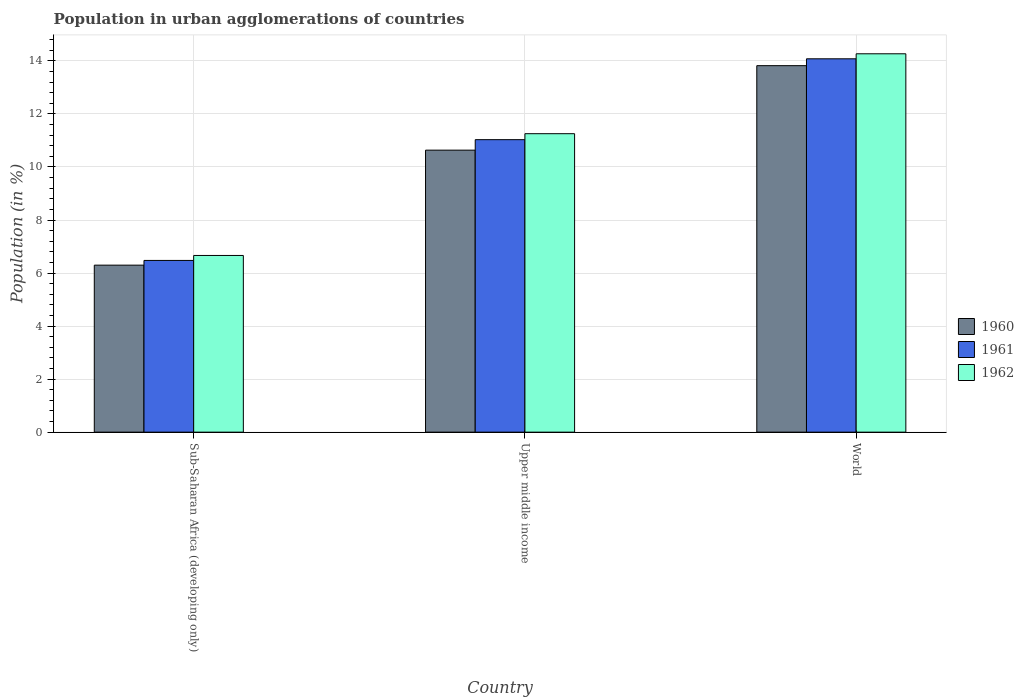How many groups of bars are there?
Your answer should be compact. 3. Are the number of bars per tick equal to the number of legend labels?
Your response must be concise. Yes. How many bars are there on the 2nd tick from the right?
Your response must be concise. 3. What is the label of the 2nd group of bars from the left?
Offer a very short reply. Upper middle income. What is the percentage of population in urban agglomerations in 1962 in World?
Offer a very short reply. 14.27. Across all countries, what is the maximum percentage of population in urban agglomerations in 1961?
Make the answer very short. 14.08. Across all countries, what is the minimum percentage of population in urban agglomerations in 1962?
Keep it short and to the point. 6.66. In which country was the percentage of population in urban agglomerations in 1960 maximum?
Provide a succinct answer. World. In which country was the percentage of population in urban agglomerations in 1960 minimum?
Provide a short and direct response. Sub-Saharan Africa (developing only). What is the total percentage of population in urban agglomerations in 1962 in the graph?
Provide a succinct answer. 32.19. What is the difference between the percentage of population in urban agglomerations in 1962 in Sub-Saharan Africa (developing only) and that in World?
Your answer should be compact. -7.61. What is the difference between the percentage of population in urban agglomerations in 1960 in Upper middle income and the percentage of population in urban agglomerations in 1961 in World?
Provide a succinct answer. -3.45. What is the average percentage of population in urban agglomerations in 1961 per country?
Your answer should be very brief. 10.53. What is the difference between the percentage of population in urban agglomerations of/in 1960 and percentage of population in urban agglomerations of/in 1962 in Sub-Saharan Africa (developing only)?
Provide a short and direct response. -0.37. What is the ratio of the percentage of population in urban agglomerations in 1960 in Sub-Saharan Africa (developing only) to that in World?
Provide a short and direct response. 0.46. Is the percentage of population in urban agglomerations in 1960 in Sub-Saharan Africa (developing only) less than that in World?
Offer a very short reply. Yes. What is the difference between the highest and the second highest percentage of population in urban agglomerations in 1961?
Make the answer very short. -3.05. What is the difference between the highest and the lowest percentage of population in urban agglomerations in 1960?
Your response must be concise. 7.52. In how many countries, is the percentage of population in urban agglomerations in 1962 greater than the average percentage of population in urban agglomerations in 1962 taken over all countries?
Give a very brief answer. 2. What does the 1st bar from the left in Upper middle income represents?
Your answer should be compact. 1960. What does the 3rd bar from the right in World represents?
Give a very brief answer. 1960. Is it the case that in every country, the sum of the percentage of population in urban agglomerations in 1961 and percentage of population in urban agglomerations in 1962 is greater than the percentage of population in urban agglomerations in 1960?
Give a very brief answer. Yes. How many bars are there?
Provide a succinct answer. 9. Are all the bars in the graph horizontal?
Offer a very short reply. No. What is the difference between two consecutive major ticks on the Y-axis?
Provide a short and direct response. 2. Are the values on the major ticks of Y-axis written in scientific E-notation?
Make the answer very short. No. What is the title of the graph?
Offer a terse response. Population in urban agglomerations of countries. What is the label or title of the Y-axis?
Provide a succinct answer. Population (in %). What is the Population (in %) of 1960 in Sub-Saharan Africa (developing only)?
Make the answer very short. 6.3. What is the Population (in %) in 1961 in Sub-Saharan Africa (developing only)?
Make the answer very short. 6.48. What is the Population (in %) of 1962 in Sub-Saharan Africa (developing only)?
Your response must be concise. 6.66. What is the Population (in %) of 1960 in Upper middle income?
Provide a short and direct response. 10.63. What is the Population (in %) in 1961 in Upper middle income?
Provide a succinct answer. 11.03. What is the Population (in %) in 1962 in Upper middle income?
Offer a very short reply. 11.26. What is the Population (in %) in 1960 in World?
Give a very brief answer. 13.82. What is the Population (in %) of 1961 in World?
Provide a succinct answer. 14.08. What is the Population (in %) of 1962 in World?
Offer a very short reply. 14.27. Across all countries, what is the maximum Population (in %) in 1960?
Your response must be concise. 13.82. Across all countries, what is the maximum Population (in %) of 1961?
Give a very brief answer. 14.08. Across all countries, what is the maximum Population (in %) in 1962?
Offer a terse response. 14.27. Across all countries, what is the minimum Population (in %) in 1960?
Ensure brevity in your answer.  6.3. Across all countries, what is the minimum Population (in %) in 1961?
Give a very brief answer. 6.48. Across all countries, what is the minimum Population (in %) of 1962?
Make the answer very short. 6.66. What is the total Population (in %) of 1960 in the graph?
Ensure brevity in your answer.  30.75. What is the total Population (in %) in 1961 in the graph?
Offer a very short reply. 31.59. What is the total Population (in %) in 1962 in the graph?
Make the answer very short. 32.19. What is the difference between the Population (in %) of 1960 in Sub-Saharan Africa (developing only) and that in Upper middle income?
Give a very brief answer. -4.34. What is the difference between the Population (in %) of 1961 in Sub-Saharan Africa (developing only) and that in Upper middle income?
Your response must be concise. -4.55. What is the difference between the Population (in %) of 1962 in Sub-Saharan Africa (developing only) and that in Upper middle income?
Keep it short and to the point. -4.59. What is the difference between the Population (in %) of 1960 in Sub-Saharan Africa (developing only) and that in World?
Provide a succinct answer. -7.52. What is the difference between the Population (in %) in 1961 in Sub-Saharan Africa (developing only) and that in World?
Your response must be concise. -7.6. What is the difference between the Population (in %) of 1962 in Sub-Saharan Africa (developing only) and that in World?
Offer a terse response. -7.61. What is the difference between the Population (in %) in 1960 in Upper middle income and that in World?
Ensure brevity in your answer.  -3.19. What is the difference between the Population (in %) of 1961 in Upper middle income and that in World?
Make the answer very short. -3.05. What is the difference between the Population (in %) in 1962 in Upper middle income and that in World?
Provide a short and direct response. -3.01. What is the difference between the Population (in %) in 1960 in Sub-Saharan Africa (developing only) and the Population (in %) in 1961 in Upper middle income?
Make the answer very short. -4.73. What is the difference between the Population (in %) of 1960 in Sub-Saharan Africa (developing only) and the Population (in %) of 1962 in Upper middle income?
Your answer should be compact. -4.96. What is the difference between the Population (in %) of 1961 in Sub-Saharan Africa (developing only) and the Population (in %) of 1962 in Upper middle income?
Make the answer very short. -4.78. What is the difference between the Population (in %) in 1960 in Sub-Saharan Africa (developing only) and the Population (in %) in 1961 in World?
Offer a very short reply. -7.78. What is the difference between the Population (in %) in 1960 in Sub-Saharan Africa (developing only) and the Population (in %) in 1962 in World?
Keep it short and to the point. -7.97. What is the difference between the Population (in %) of 1961 in Sub-Saharan Africa (developing only) and the Population (in %) of 1962 in World?
Your answer should be compact. -7.79. What is the difference between the Population (in %) in 1960 in Upper middle income and the Population (in %) in 1961 in World?
Offer a terse response. -3.45. What is the difference between the Population (in %) of 1960 in Upper middle income and the Population (in %) of 1962 in World?
Give a very brief answer. -3.63. What is the difference between the Population (in %) in 1961 in Upper middle income and the Population (in %) in 1962 in World?
Ensure brevity in your answer.  -3.24. What is the average Population (in %) in 1960 per country?
Your answer should be very brief. 10.25. What is the average Population (in %) of 1961 per country?
Offer a terse response. 10.53. What is the average Population (in %) of 1962 per country?
Your answer should be compact. 10.73. What is the difference between the Population (in %) of 1960 and Population (in %) of 1961 in Sub-Saharan Africa (developing only)?
Provide a short and direct response. -0.18. What is the difference between the Population (in %) of 1960 and Population (in %) of 1962 in Sub-Saharan Africa (developing only)?
Offer a very short reply. -0.36. What is the difference between the Population (in %) in 1961 and Population (in %) in 1962 in Sub-Saharan Africa (developing only)?
Keep it short and to the point. -0.19. What is the difference between the Population (in %) in 1960 and Population (in %) in 1961 in Upper middle income?
Offer a terse response. -0.4. What is the difference between the Population (in %) of 1960 and Population (in %) of 1962 in Upper middle income?
Your answer should be very brief. -0.62. What is the difference between the Population (in %) of 1961 and Population (in %) of 1962 in Upper middle income?
Your answer should be compact. -0.23. What is the difference between the Population (in %) in 1960 and Population (in %) in 1961 in World?
Your answer should be compact. -0.26. What is the difference between the Population (in %) of 1960 and Population (in %) of 1962 in World?
Make the answer very short. -0.45. What is the difference between the Population (in %) of 1961 and Population (in %) of 1962 in World?
Your response must be concise. -0.19. What is the ratio of the Population (in %) in 1960 in Sub-Saharan Africa (developing only) to that in Upper middle income?
Make the answer very short. 0.59. What is the ratio of the Population (in %) in 1961 in Sub-Saharan Africa (developing only) to that in Upper middle income?
Make the answer very short. 0.59. What is the ratio of the Population (in %) of 1962 in Sub-Saharan Africa (developing only) to that in Upper middle income?
Provide a succinct answer. 0.59. What is the ratio of the Population (in %) of 1960 in Sub-Saharan Africa (developing only) to that in World?
Offer a terse response. 0.46. What is the ratio of the Population (in %) in 1961 in Sub-Saharan Africa (developing only) to that in World?
Give a very brief answer. 0.46. What is the ratio of the Population (in %) of 1962 in Sub-Saharan Africa (developing only) to that in World?
Offer a very short reply. 0.47. What is the ratio of the Population (in %) of 1960 in Upper middle income to that in World?
Your answer should be very brief. 0.77. What is the ratio of the Population (in %) of 1961 in Upper middle income to that in World?
Keep it short and to the point. 0.78. What is the ratio of the Population (in %) of 1962 in Upper middle income to that in World?
Give a very brief answer. 0.79. What is the difference between the highest and the second highest Population (in %) in 1960?
Your response must be concise. 3.19. What is the difference between the highest and the second highest Population (in %) of 1961?
Your answer should be very brief. 3.05. What is the difference between the highest and the second highest Population (in %) in 1962?
Give a very brief answer. 3.01. What is the difference between the highest and the lowest Population (in %) in 1960?
Your response must be concise. 7.52. What is the difference between the highest and the lowest Population (in %) in 1961?
Provide a short and direct response. 7.6. What is the difference between the highest and the lowest Population (in %) of 1962?
Offer a very short reply. 7.61. 